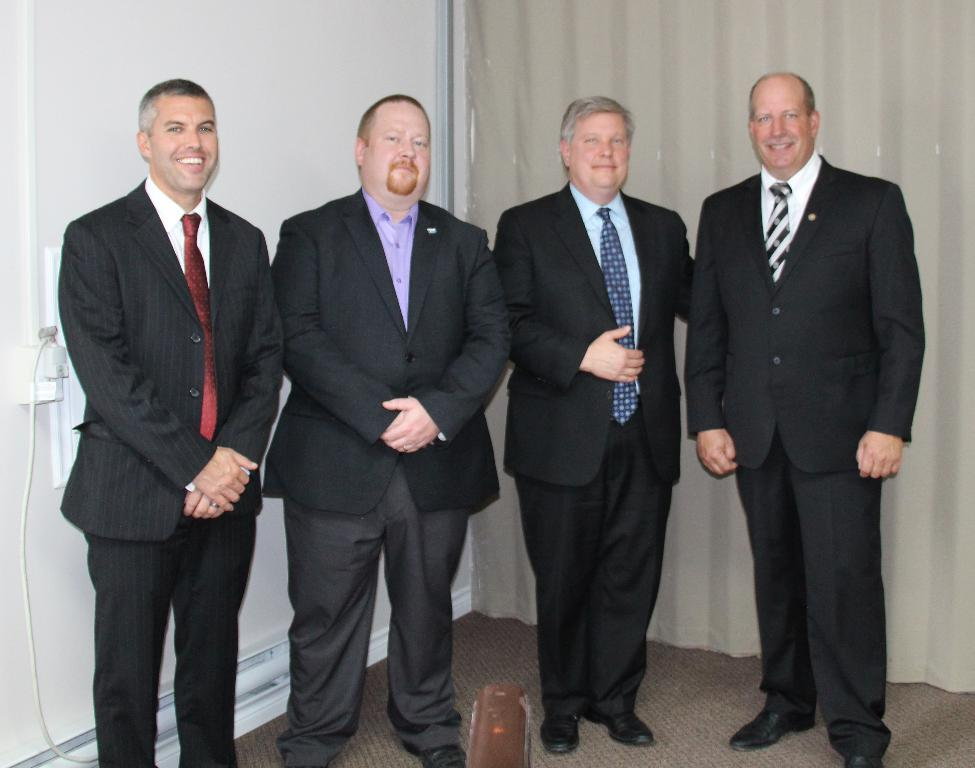What can be seen in the image involving people? There are persons standing in the image. What are the persons wearing? The persons are wearing clothes. What is on the left side of the image? There is a wall on the left side of the image. What is on the right side of the image? There is a curtain on the right side of the image. What type of furniture is being thought about by the persons in the image? There is no indication in the image that the persons are thinking about any furniture. 